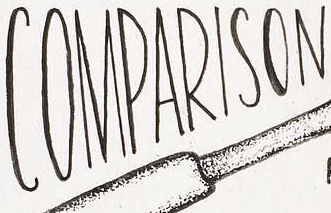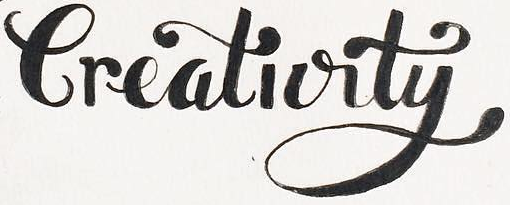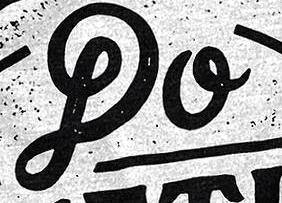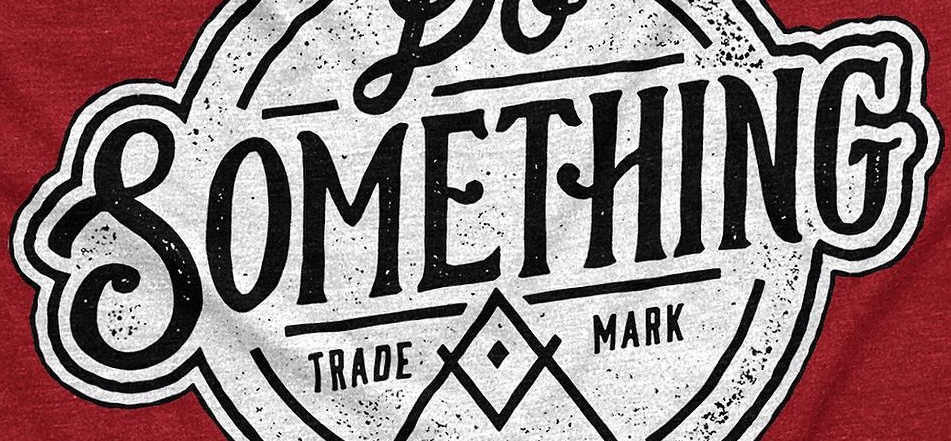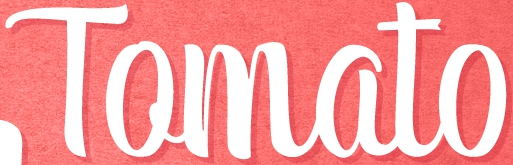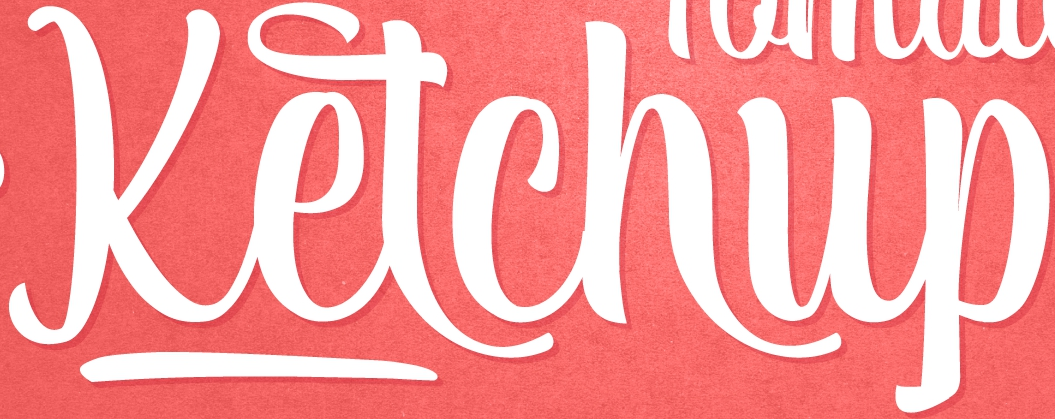What words are shown in these images in order, separated by a semicolon? COMPARISON; Creativity; DO; SOMETHING; Tomato; Ketchup 